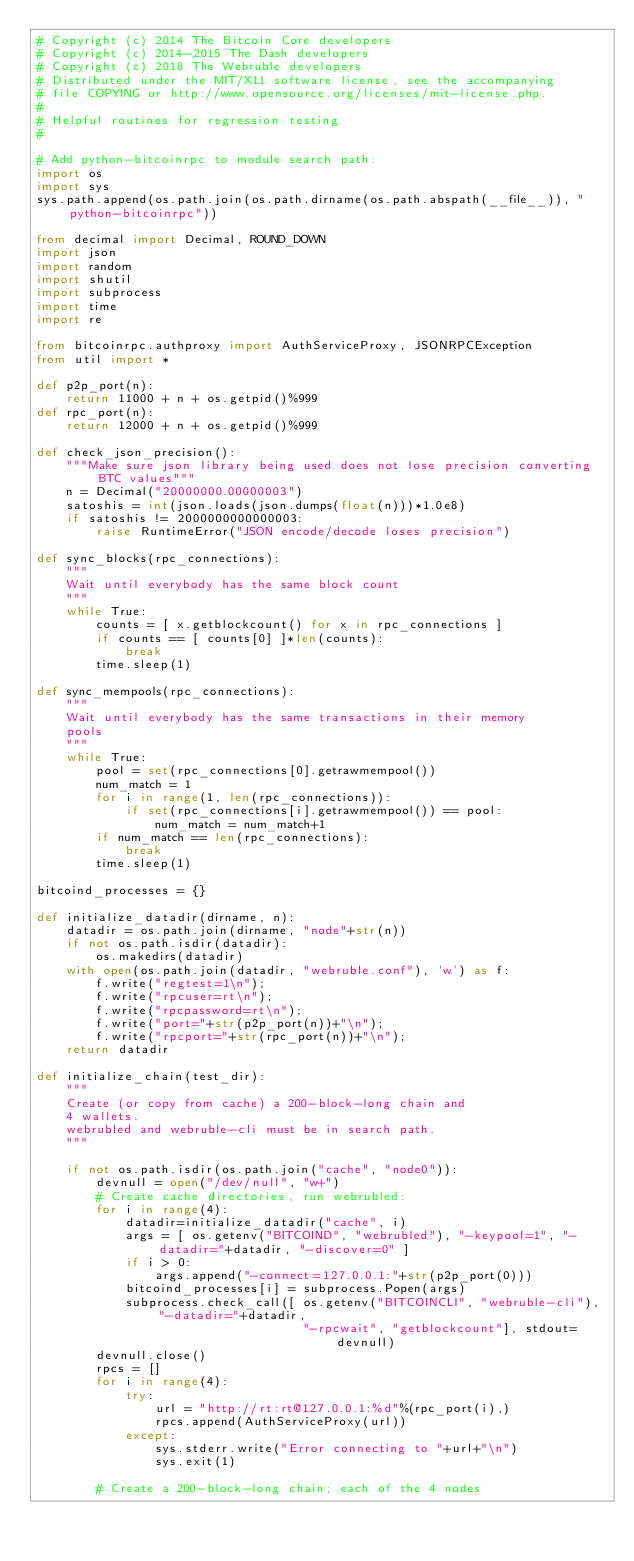Convert code to text. <code><loc_0><loc_0><loc_500><loc_500><_Python_># Copyright (c) 2014 The Bitcoin Core developers
# Copyright (c) 2014-2015 The Dash developers
# Copyright (c) 2018 The Webruble developers
# Distributed under the MIT/X11 software license, see the accompanying
# file COPYING or http://www.opensource.org/licenses/mit-license.php.
#
# Helpful routines for regression testing
#

# Add python-bitcoinrpc to module search path:
import os
import sys
sys.path.append(os.path.join(os.path.dirname(os.path.abspath(__file__)), "python-bitcoinrpc"))

from decimal import Decimal, ROUND_DOWN
import json
import random
import shutil
import subprocess
import time
import re

from bitcoinrpc.authproxy import AuthServiceProxy, JSONRPCException
from util import *

def p2p_port(n):
    return 11000 + n + os.getpid()%999
def rpc_port(n):
    return 12000 + n + os.getpid()%999

def check_json_precision():
    """Make sure json library being used does not lose precision converting BTC values"""
    n = Decimal("20000000.00000003")
    satoshis = int(json.loads(json.dumps(float(n)))*1.0e8)
    if satoshis != 2000000000000003:
        raise RuntimeError("JSON encode/decode loses precision")

def sync_blocks(rpc_connections):
    """
    Wait until everybody has the same block count
    """
    while True:
        counts = [ x.getblockcount() for x in rpc_connections ]
        if counts == [ counts[0] ]*len(counts):
            break
        time.sleep(1)

def sync_mempools(rpc_connections):
    """
    Wait until everybody has the same transactions in their memory
    pools
    """
    while True:
        pool = set(rpc_connections[0].getrawmempool())
        num_match = 1
        for i in range(1, len(rpc_connections)):
            if set(rpc_connections[i].getrawmempool()) == pool:
                num_match = num_match+1
        if num_match == len(rpc_connections):
            break
        time.sleep(1)

bitcoind_processes = {}

def initialize_datadir(dirname, n):
    datadir = os.path.join(dirname, "node"+str(n))
    if not os.path.isdir(datadir):
        os.makedirs(datadir)
    with open(os.path.join(datadir, "webruble.conf"), 'w') as f:
        f.write("regtest=1\n");
        f.write("rpcuser=rt\n");
        f.write("rpcpassword=rt\n");
        f.write("port="+str(p2p_port(n))+"\n");
        f.write("rpcport="+str(rpc_port(n))+"\n");
    return datadir

def initialize_chain(test_dir):
    """
    Create (or copy from cache) a 200-block-long chain and
    4 wallets.
    webrubled and webruble-cli must be in search path.
    """

    if not os.path.isdir(os.path.join("cache", "node0")):
        devnull = open("/dev/null", "w+")
        # Create cache directories, run webrubled:
        for i in range(4):
            datadir=initialize_datadir("cache", i)
            args = [ os.getenv("BITCOIND", "webrubled"), "-keypool=1", "-datadir="+datadir, "-discover=0" ]
            if i > 0:
                args.append("-connect=127.0.0.1:"+str(p2p_port(0)))
            bitcoind_processes[i] = subprocess.Popen(args)
            subprocess.check_call([ os.getenv("BITCOINCLI", "webruble-cli"), "-datadir="+datadir,
                                    "-rpcwait", "getblockcount"], stdout=devnull)
        devnull.close()
        rpcs = []
        for i in range(4):
            try:
                url = "http://rt:rt@127.0.0.1:%d"%(rpc_port(i),)
                rpcs.append(AuthServiceProxy(url))
            except:
                sys.stderr.write("Error connecting to "+url+"\n")
                sys.exit(1)

        # Create a 200-block-long chain; each of the 4 nodes</code> 